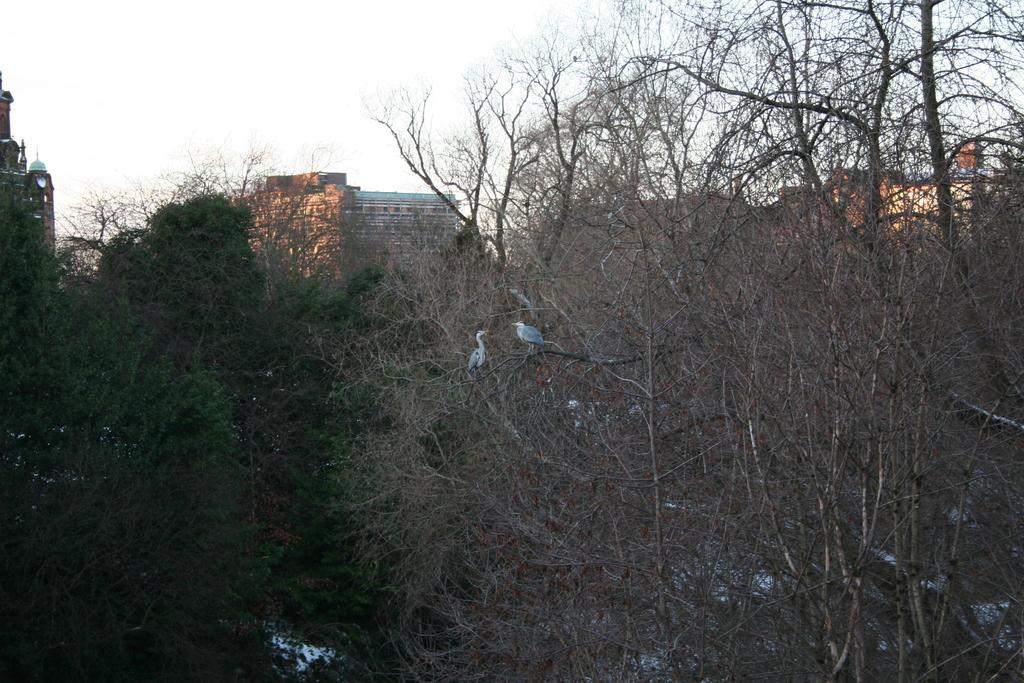How many birds are in the image? There are two birds in the image. Where are the birds located in the image? The birds are sitting on a tree. What can be seen in the foreground of the image? There are trees in the foreground of the image. What is visible in the background of the image? There are buildings visible in the background of the image. What part of the natural environment is visible in the image? The sky is visible at the top of the image, and there is water visible at the bottom of the image. What type of ornament is hanging from the birds' necks in the image? There are no ornaments hanging from the birds' necks in the image. How comfortable are the birds sitting on the tree in the image? The comfort level of the birds cannot be determined from the image. 